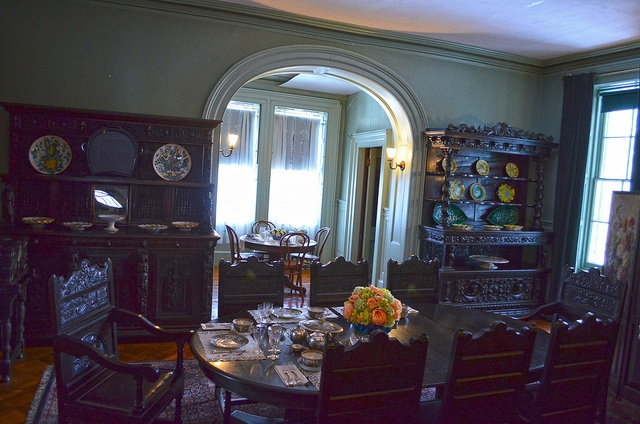Describe the objects in this image and their specific colors. I can see dining table in black, gray, and maroon tones, chair in black, navy, maroon, and purple tones, chair in black, maroon, navy, and gray tones, chair in black, maroon, and purple tones, and chair in black, navy, and gray tones in this image. 